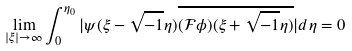<formula> <loc_0><loc_0><loc_500><loc_500>\lim _ { | \xi | \to \infty } \int _ { 0 } ^ { \eta _ { 0 } } | \psi ( \xi - \sqrt { - 1 } \eta ) \overline { ( \mathcal { F } \phi ) ( \xi + \sqrt { - 1 } \eta ) } | d \eta = 0</formula> 